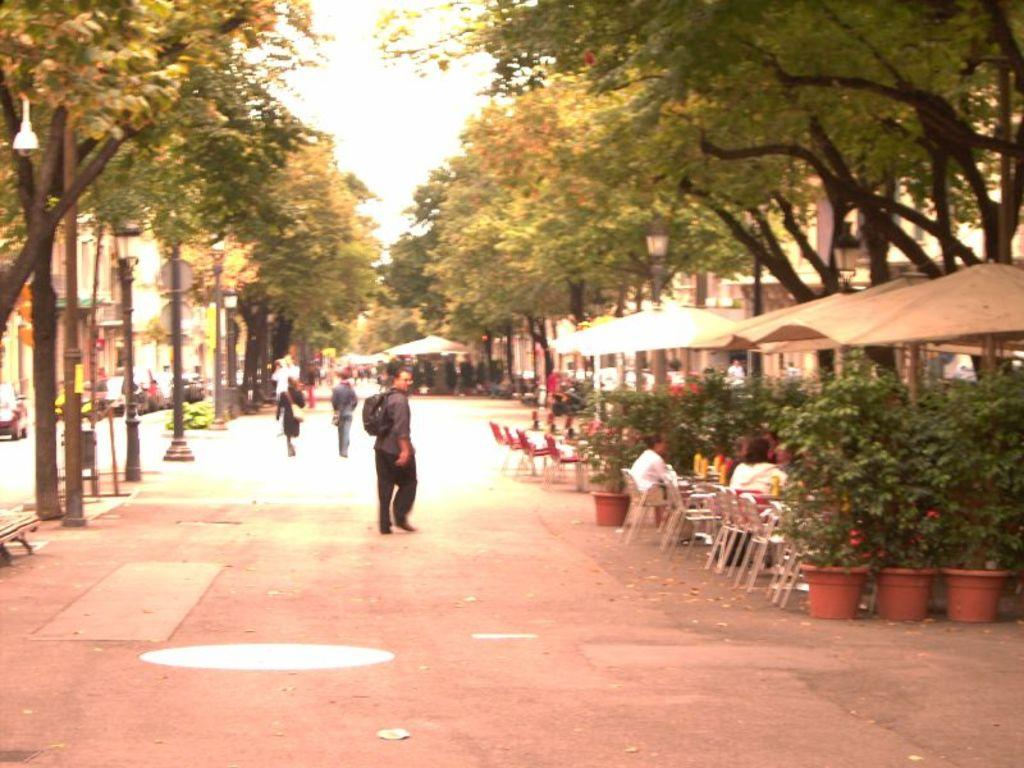What structures are located beside the road in the image? There are tents beside the road in the image. What are some people doing in the image? Some people are sitting on chairs in the image. What activity are other people engaged in within the image? Some people are walking on the road in the image. What type of arithmetic problem is being solved by the stick in the image? There is no stick or arithmetic problem present in the image. What is the hope of the people sitting on chairs in the image? The provided facts do not mention the hopes or intentions of the people sitting on chairs in the image. 